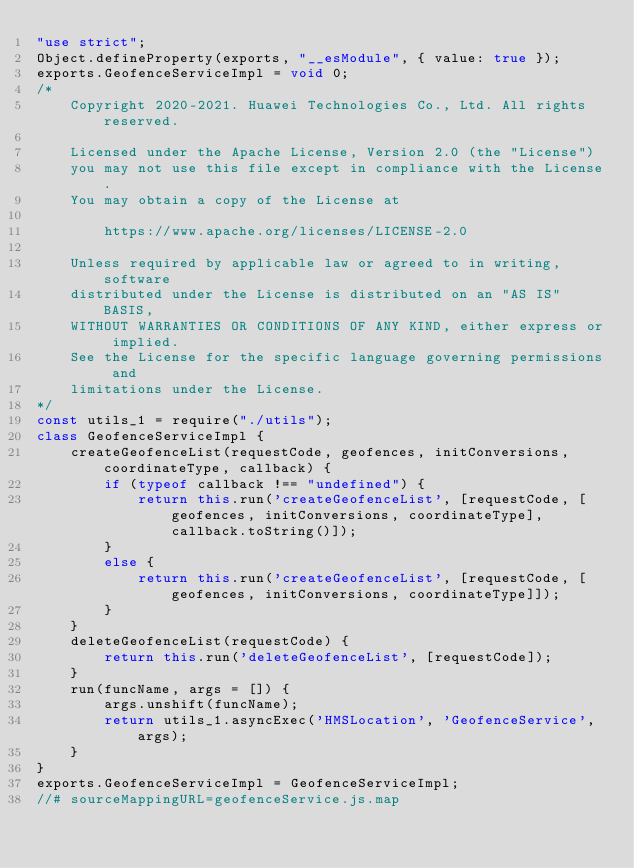<code> <loc_0><loc_0><loc_500><loc_500><_JavaScript_>"use strict";
Object.defineProperty(exports, "__esModule", { value: true });
exports.GeofenceServiceImpl = void 0;
/*
    Copyright 2020-2021. Huawei Technologies Co., Ltd. All rights reserved.

    Licensed under the Apache License, Version 2.0 (the "License")
    you may not use this file except in compliance with the License.
    You may obtain a copy of the License at

        https://www.apache.org/licenses/LICENSE-2.0

    Unless required by applicable law or agreed to in writing, software
    distributed under the License is distributed on an "AS IS" BASIS,
    WITHOUT WARRANTIES OR CONDITIONS OF ANY KIND, either express or implied.
    See the License for the specific language governing permissions and
    limitations under the License.
*/
const utils_1 = require("./utils");
class GeofenceServiceImpl {
    createGeofenceList(requestCode, geofences, initConversions, coordinateType, callback) {
        if (typeof callback !== "undefined") {
            return this.run('createGeofenceList', [requestCode, [geofences, initConversions, coordinateType], callback.toString()]);
        }
        else {
            return this.run('createGeofenceList', [requestCode, [geofences, initConversions, coordinateType]]);
        }
    }
    deleteGeofenceList(requestCode) {
        return this.run('deleteGeofenceList', [requestCode]);
    }
    run(funcName, args = []) {
        args.unshift(funcName);
        return utils_1.asyncExec('HMSLocation', 'GeofenceService', args);
    }
}
exports.GeofenceServiceImpl = GeofenceServiceImpl;
//# sourceMappingURL=geofenceService.js.map</code> 